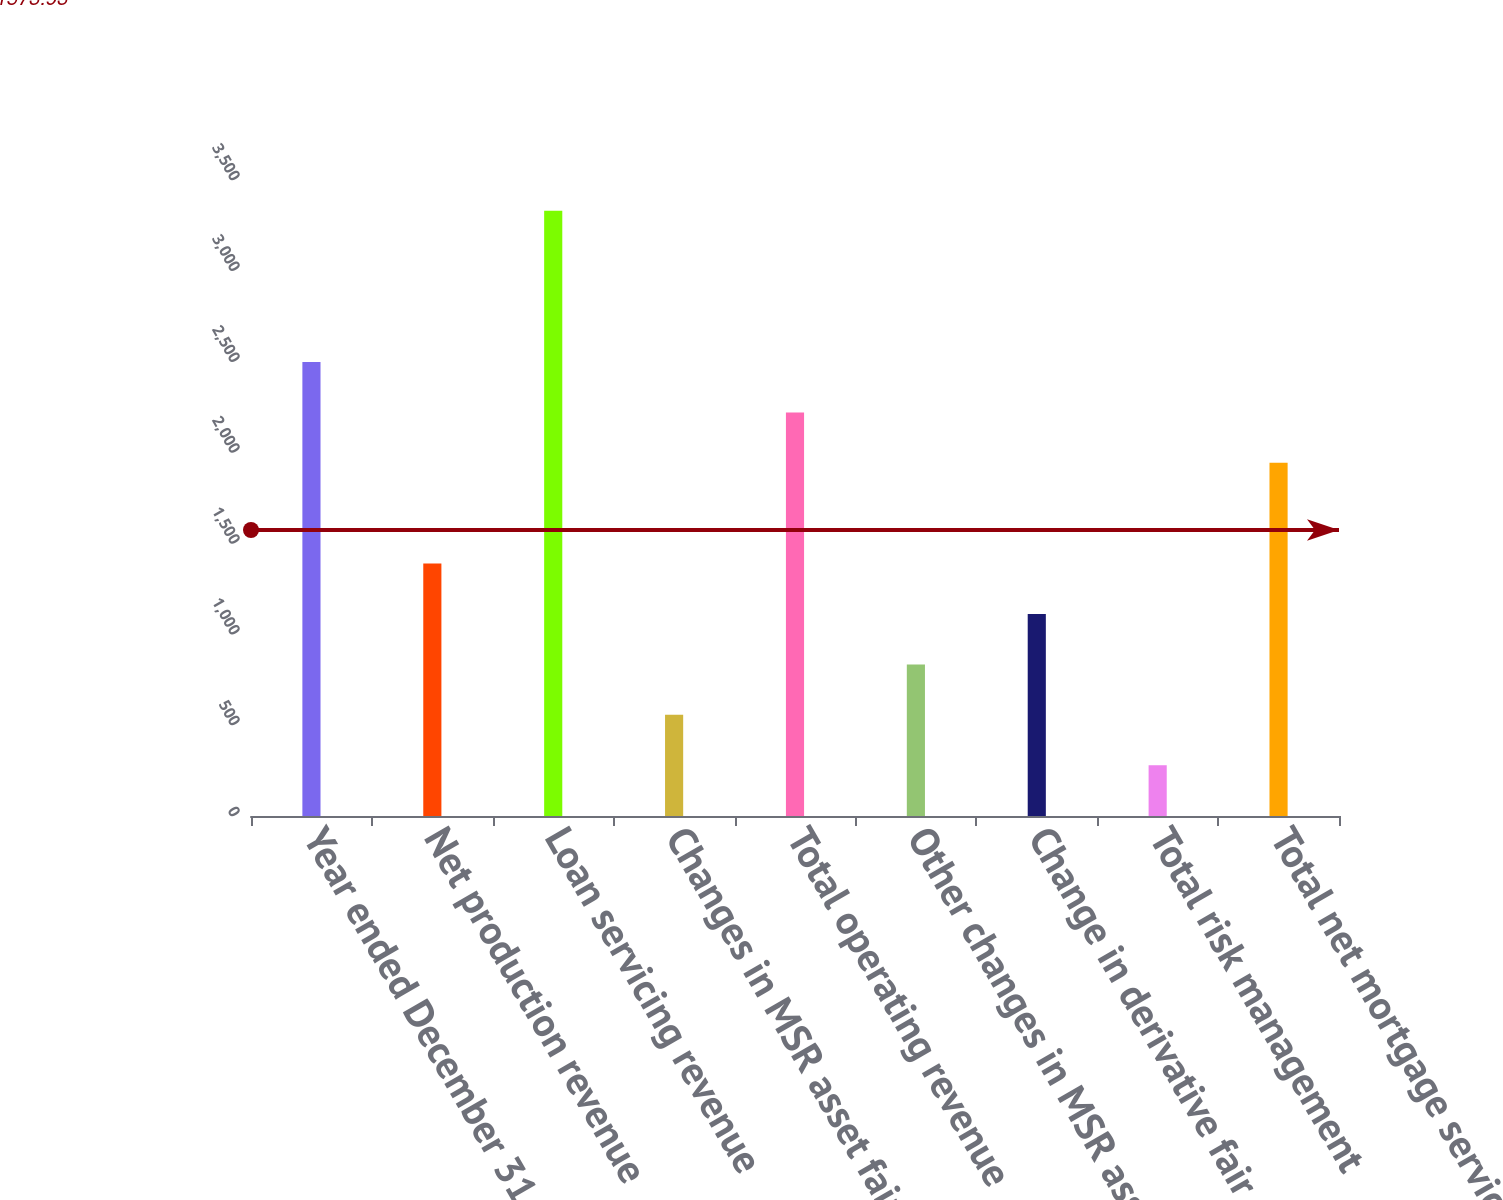Convert chart. <chart><loc_0><loc_0><loc_500><loc_500><bar_chart><fcel>Year ended December 31 (in<fcel>Net production revenue<fcel>Loan servicing revenue<fcel>Changes in MSR asset fair<fcel>Total operating revenue<fcel>Other changes in MSR asset<fcel>Change in derivative fair<fcel>Total risk management<fcel>Total net mortgage servicing<nl><fcel>2498.6<fcel>1389<fcel>3330.8<fcel>556.8<fcel>2221.2<fcel>834.2<fcel>1111.6<fcel>279.4<fcel>1943.8<nl></chart> 